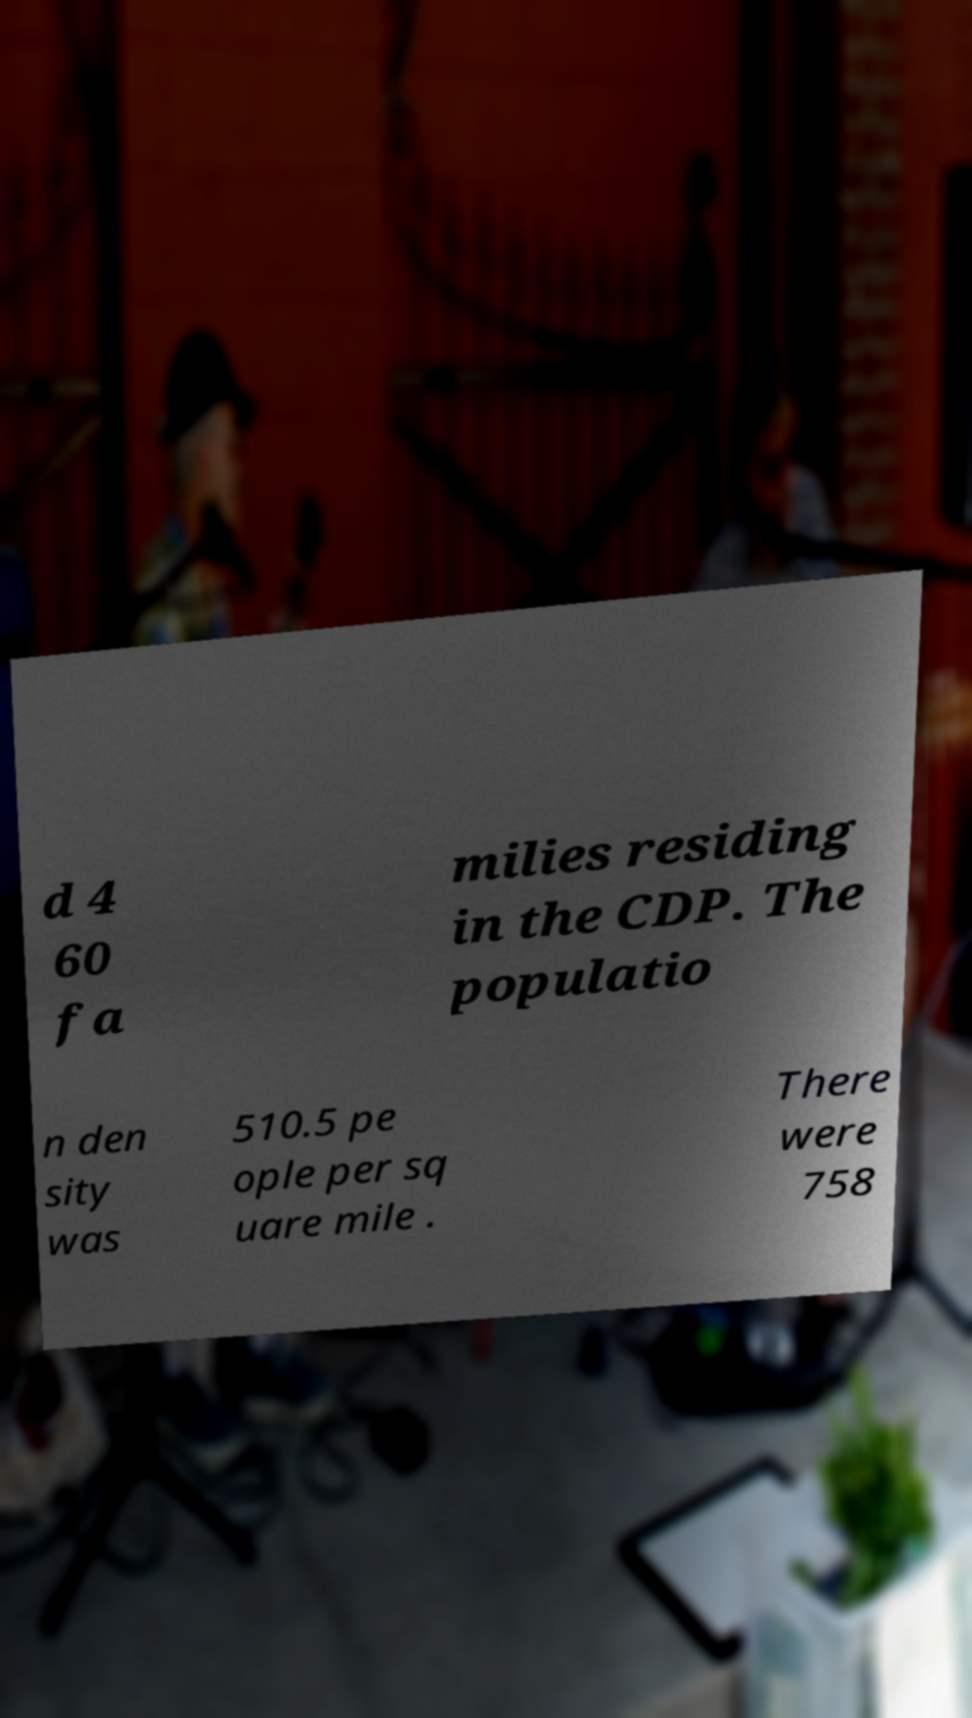Please read and relay the text visible in this image. What does it say? d 4 60 fa milies residing in the CDP. The populatio n den sity was 510.5 pe ople per sq uare mile . There were 758 